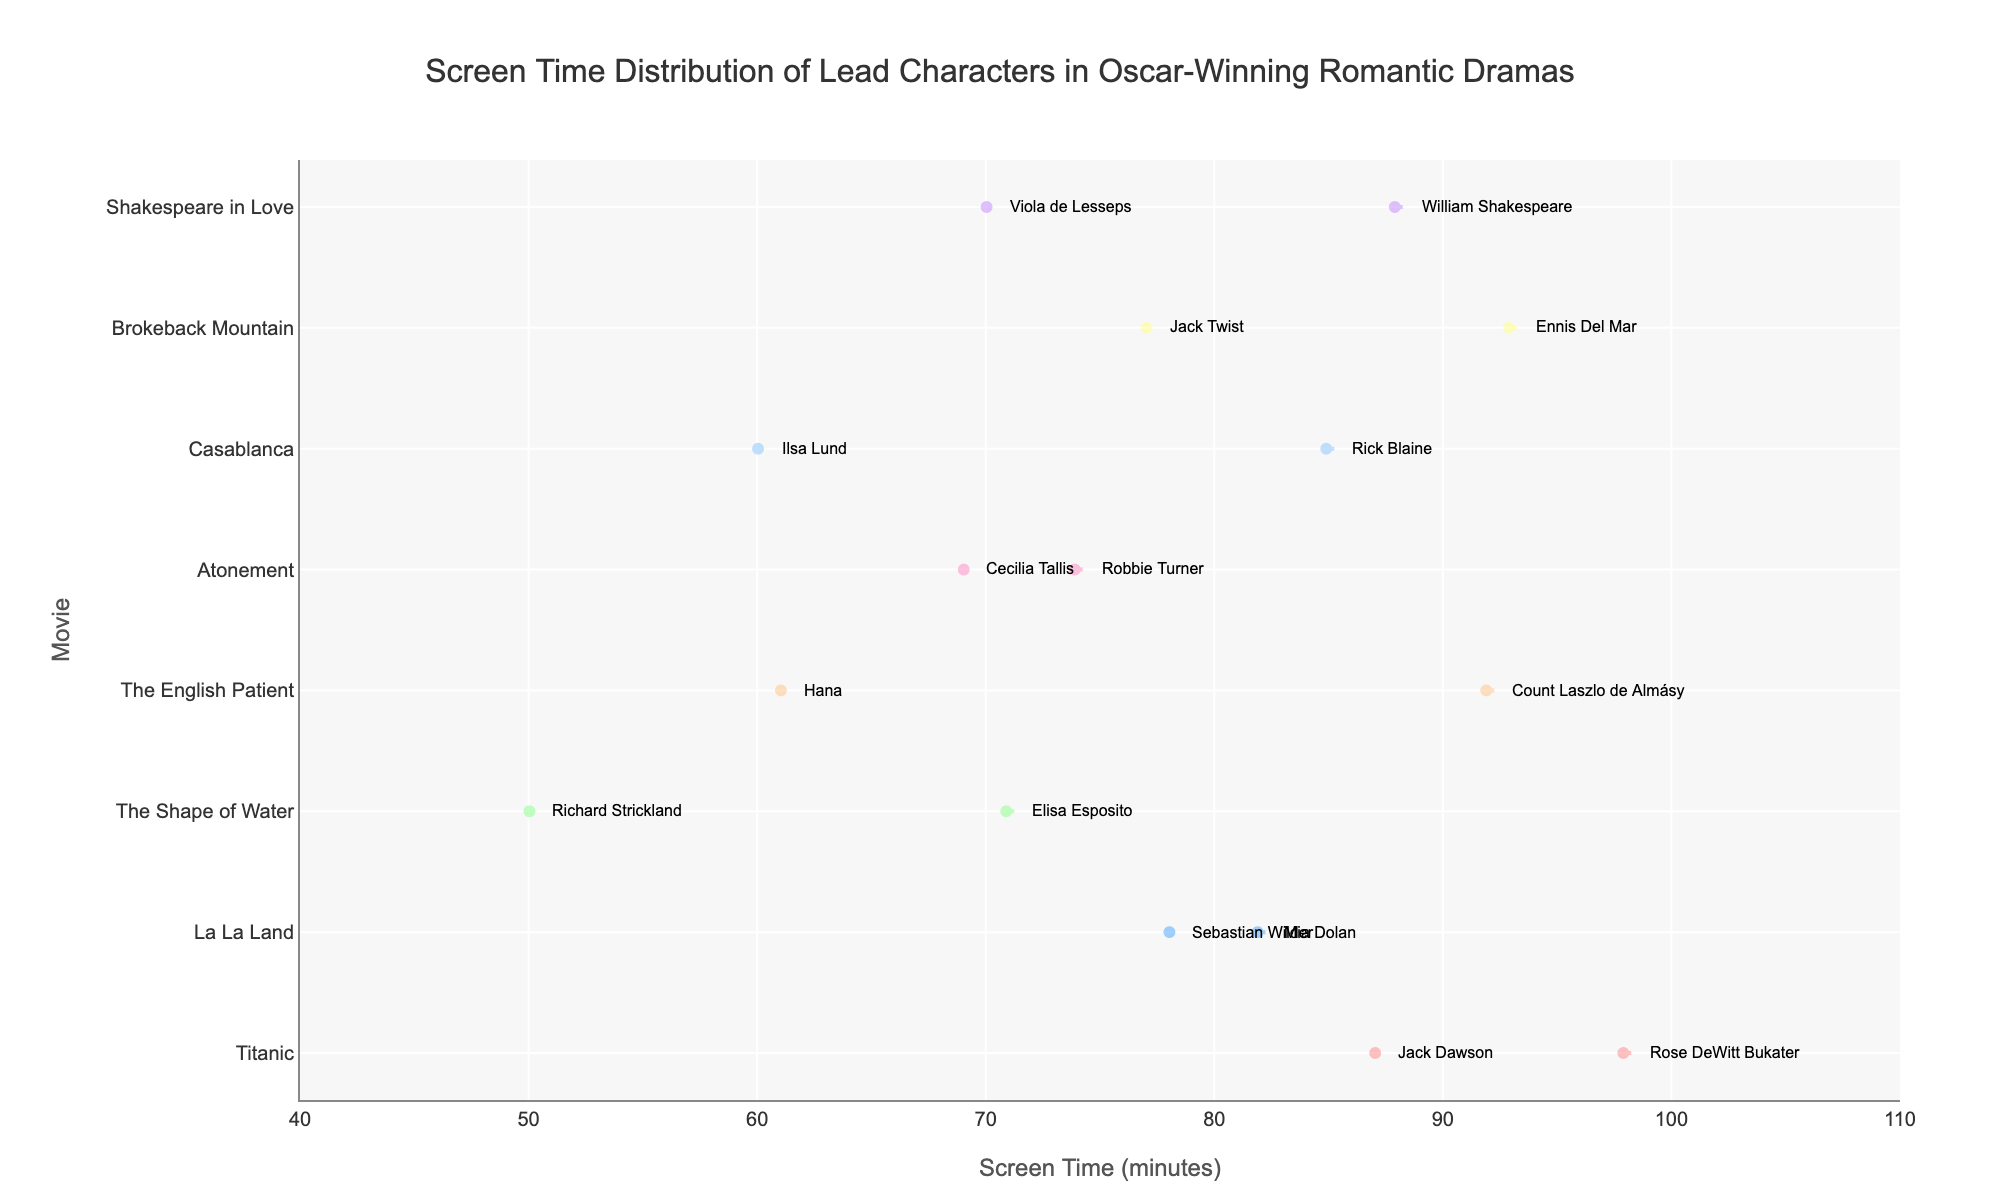what's the title of the chart? The title is prominently displayed at the top center of the chart. It serves as a brief description of what the chart represents.
Answer: Screen Time Distribution of Lead Characters in Oscar-Winning Romantic Dramas How many data points are there for the movie La La Land? Locate the La La Land distribution on the y-axis and count the number of dots within its violin plot. Each dot represents a lead character's screen time.
Answer: 2 Which character has the highest screen time in Titanic? Within Titanic's violin plot, identify the data point at the maximum x-value and read the associated annotation for the character's name.
Answer: Rose DeWitt Bukater Between Casablanca and The English Patient, which movie has a greater range of screen times? Compare the extents of the horizontal spreads (violin plots) for both movies and determine which has a larger range.
Answer: The English Patient What is the median screen time for Brokeback Mountain? Identify the thick horizontal line inside Brokeback Mountain's violin plot, as it represents the median of the distribution.
Answer: 85 How does the screen time of Mia Dolan in La La Land compare to Elisa Esposito in The Shape of Water? Refer to La La Land to find Mia Dolan's screen time and compare it with Elisa Esposito's in The Shape of Water, noting which one is higher.
Answer: Mia Dolan has more screen time Which movie has the most closely clustered screen times for its lead characters? Look for the violin plot that's narrowest, indicating closely clustered screen times around the mean.
Answer: The Shape of Water On average, do male or female characters have more screen time in these movies? Calculate the average screen time for male and female characters across all movies and compare the two averages.
Answer: Male characters have more screen time Which movies have at least one character with a screen time of over 90 minutes? Scan the chart for violin plots extending beyond the 90-minute mark and list their associated movies.
Answer: Titanic, The English Patient, Brokeback Mountain, Shakespeare in Love Are the screen times for lead characters in Atonement more evenly distributed than in Titanic? Compare the spreads and shapes of Atonement and Titanic's violin plots to see if Atonement's is more uniform and less skewed.
Answer: No, Titanic's distribution is more even 